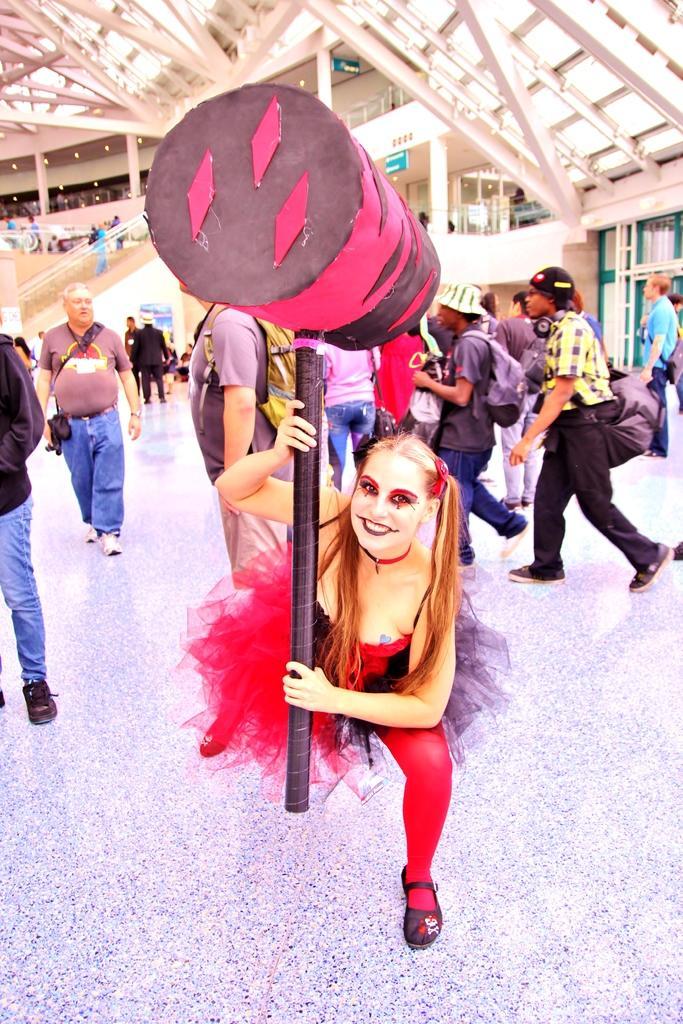Describe this image in one or two sentences. At the bottom of this image, there is a woman in a red color dress, holding an object, smiling and holding an object. In the background, there are other persons, a roof, sign boards and other objects. 